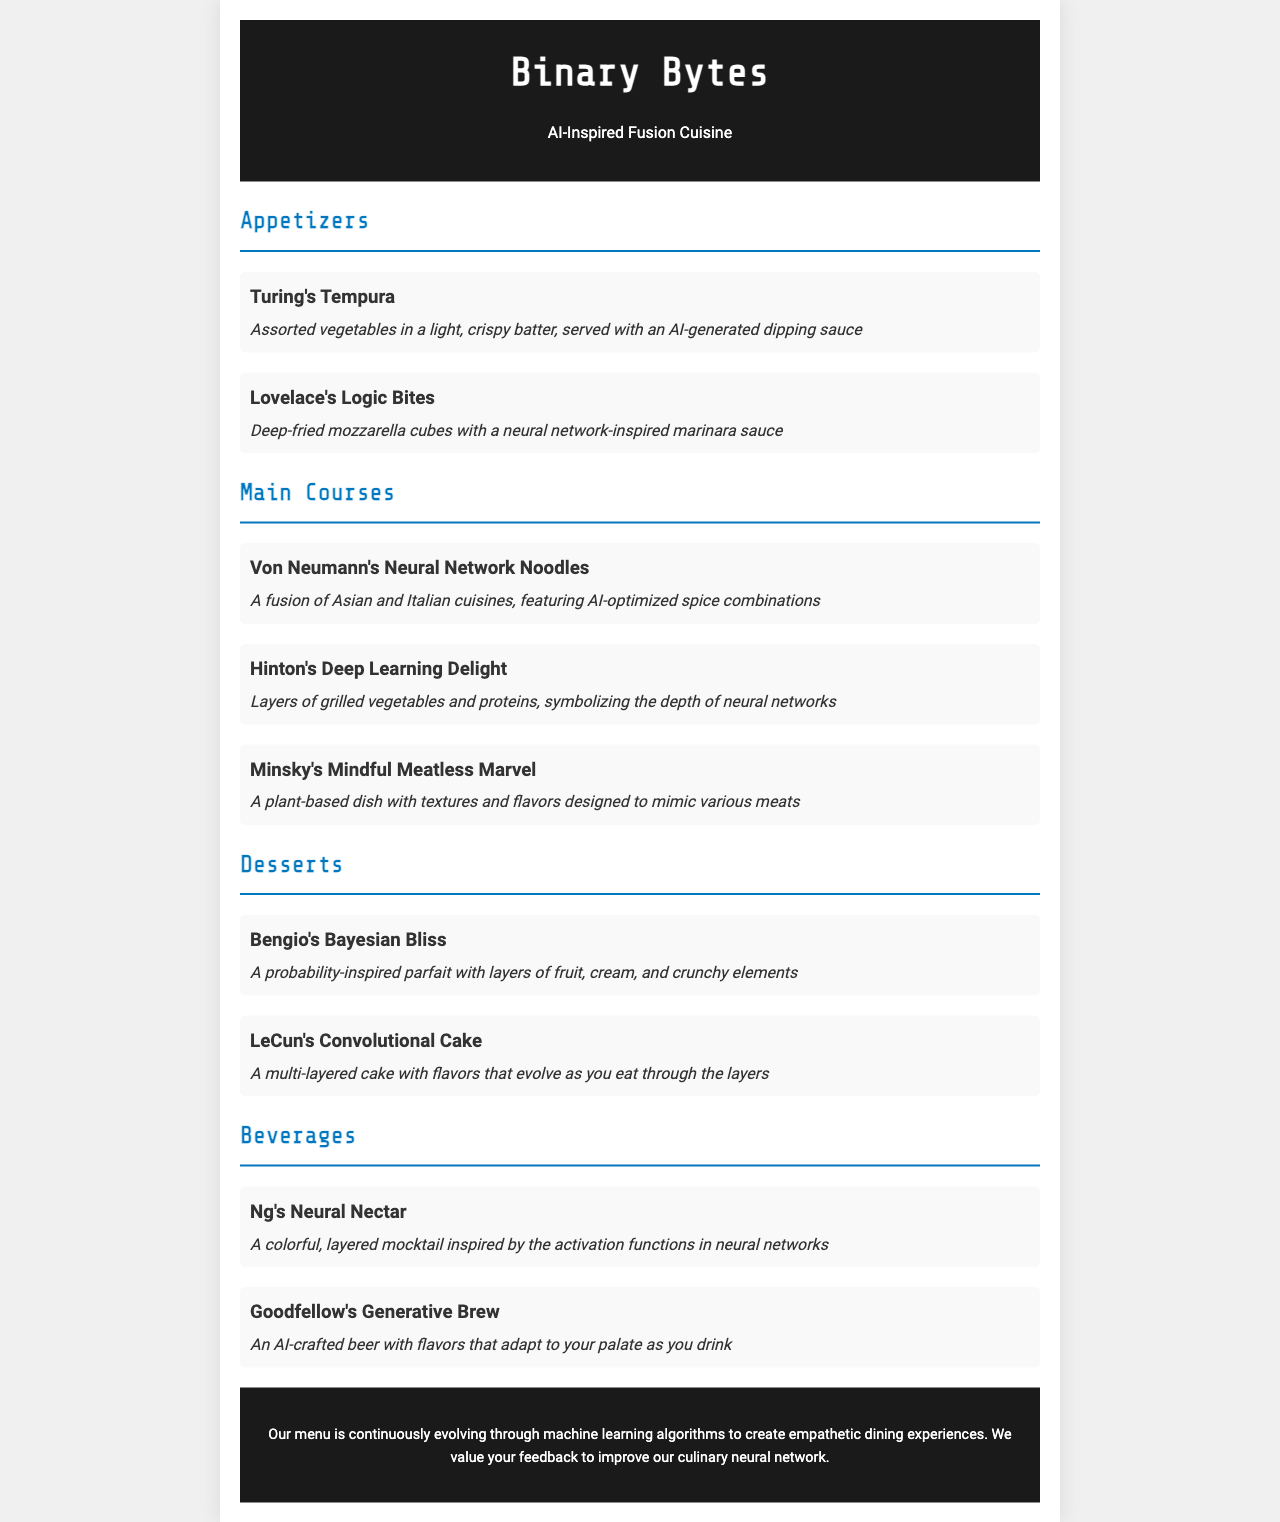What is the name of the restaurant? The name is prominently displayed in the header of the document.
Answer: Binary Bytes What dish features assorted vegetables? The document lists dishes with descriptions; one mentions assorted vegetables specifically.
Answer: Turing's Tempura Which scientist is associated with a plant-based dish? The menu specifies the dish related to a computer scientist who focuses on plant-based cuisine.
Answer: Minsky's Mindful Meatless Marvel How many appetizers are listed? The appetizers section contains a specific number of dishes mentioned.
Answer: 2 What type of drink is inspired by neural networks? The beverages section explicitly describes a drink related to neural networks.
Answer: Ng's Neural Nectar Which dessert has layers of fruit? The menu describes desserts, indicating one has layers of fruit.
Answer: Bengio's Bayesian Bliss What is the theme of the restaurant's cuisine? The main theme is highlighted in the title and throughout the document.
Answer: AI-Inspired Fusion Cuisine What dish symbolizes the depth of neural networks? The descriptions provide insight into the symbolism behind a specific dish.
Answer: Hinton's Deep Learning Delight 